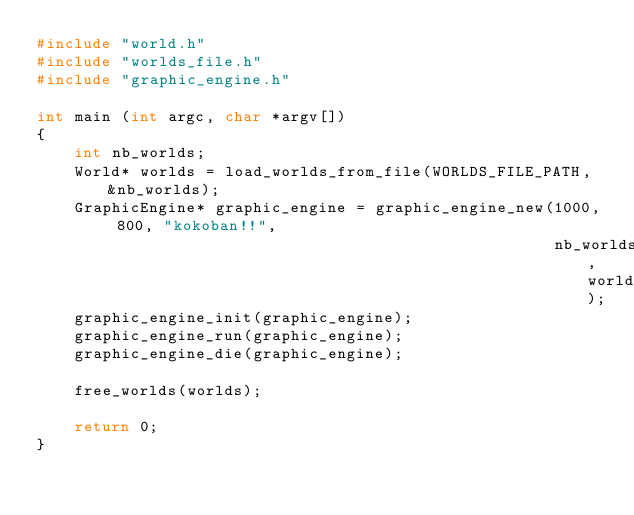<code> <loc_0><loc_0><loc_500><loc_500><_C_>#include "world.h"
#include "worlds_file.h"
#include "graphic_engine.h"

int main (int argc, char *argv[])
{
    int nb_worlds;
    World* worlds = load_worlds_from_file(WORLDS_FILE_PATH, &nb_worlds);
    GraphicEngine* graphic_engine = graphic_engine_new(1000, 800, "kokoban!!", 
                                                       nb_worlds, worlds);
    graphic_engine_init(graphic_engine);
    graphic_engine_run(graphic_engine);
    graphic_engine_die(graphic_engine);

    free_worlds(worlds);

    return 0;
}</code> 